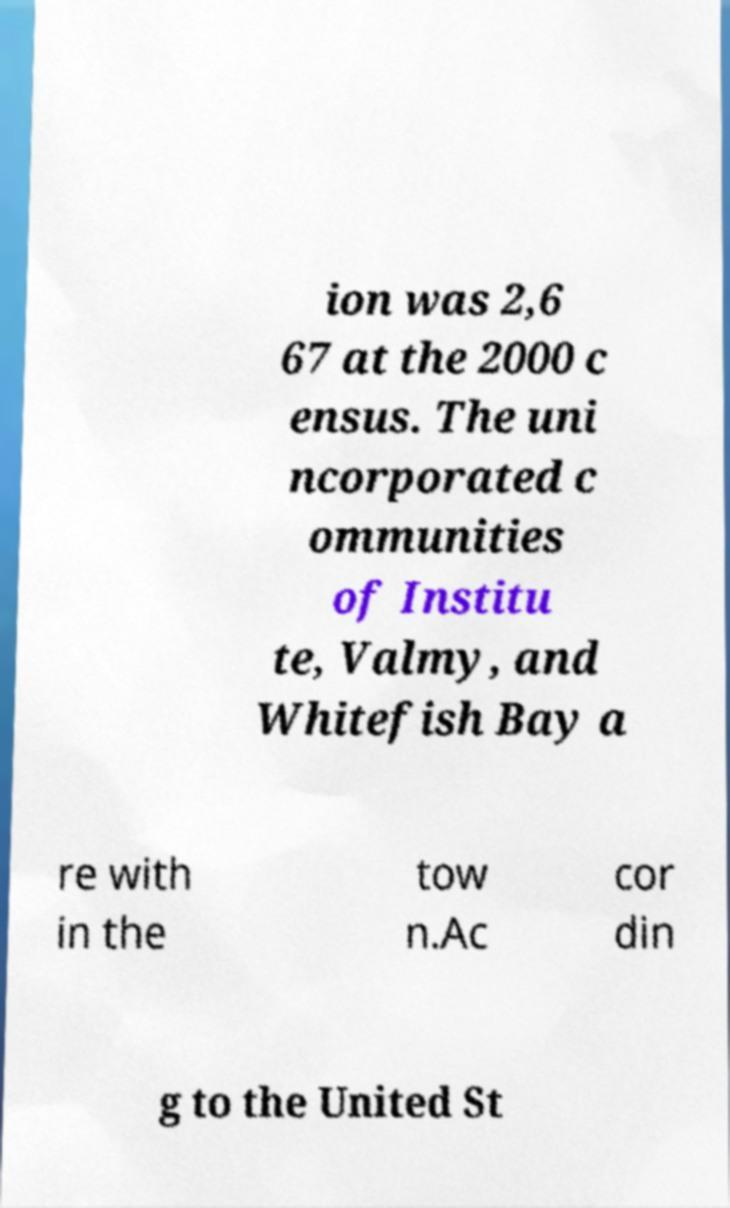Please read and relay the text visible in this image. What does it say? ion was 2,6 67 at the 2000 c ensus. The uni ncorporated c ommunities of Institu te, Valmy, and Whitefish Bay a re with in the tow n.Ac cor din g to the United St 